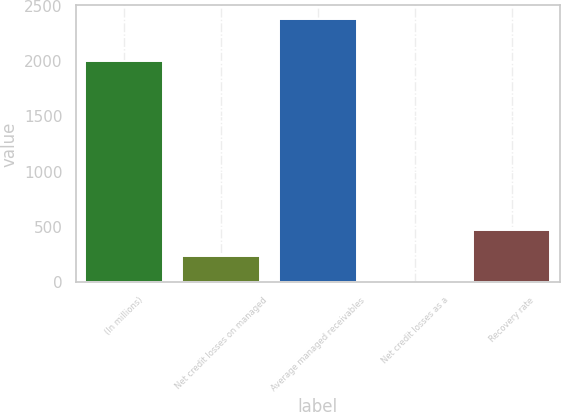Convert chart. <chart><loc_0><loc_0><loc_500><loc_500><bar_chart><fcel>(In millions)<fcel>Net credit losses on managed<fcel>Average managed receivables<fcel>Net credit losses as a<fcel>Recovery rate<nl><fcel>2005<fcel>239.1<fcel>2383.6<fcel>0.82<fcel>477.38<nl></chart> 